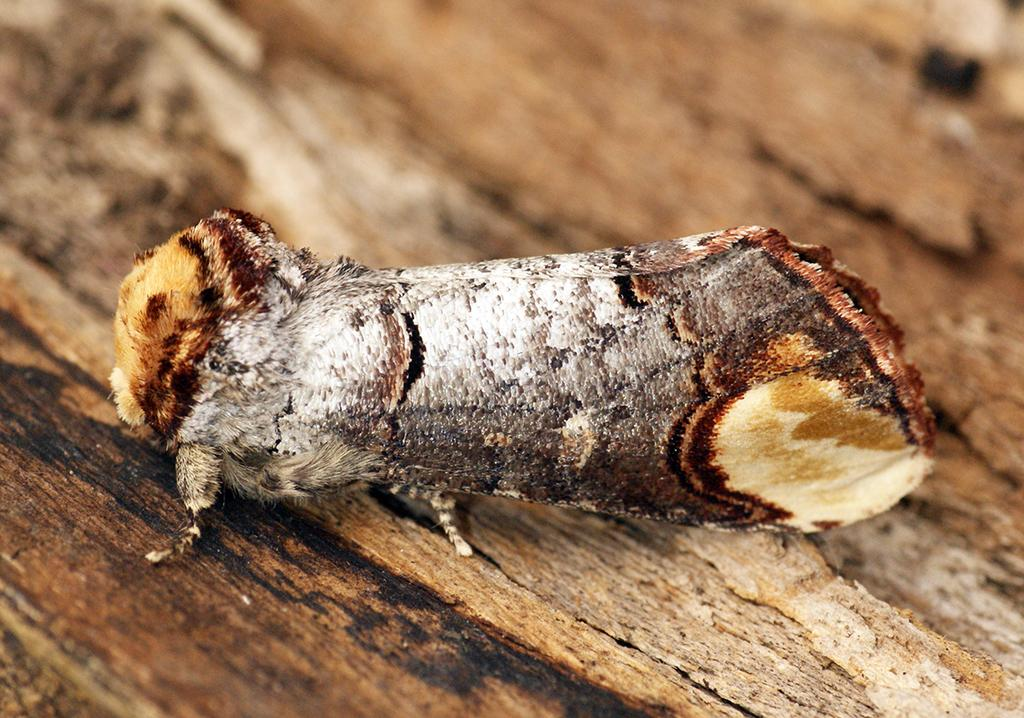What is located in the foreground of the image? There is an insect in the foreground of the image. What is the insect situated on? The insect is on a wooden object. What type of horse can be seen in the image? There is no horse present in the image; it features an insect on a wooden object. How is the quilt used to measure the distance between the insect and the wooden object? There is no quilt present in the image, and therefore it cannot be used to measure any distances. 